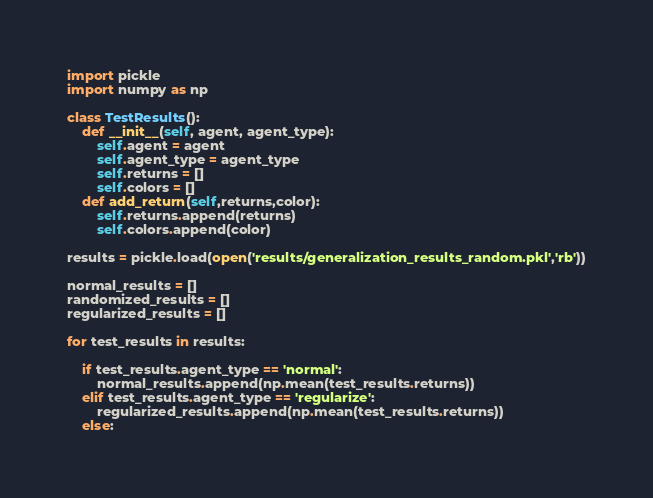Convert code to text. <code><loc_0><loc_0><loc_500><loc_500><_Python_>import pickle
import numpy as np

class TestResults():
    def __init__(self, agent, agent_type):
        self.agent = agent
        self.agent_type = agent_type
        self.returns = []
        self.colors = []
    def add_return(self,returns,color):
        self.returns.append(returns)
        self.colors.append(color)

results = pickle.load(open('results/generalization_results_random.pkl','rb'))

normal_results = []
randomized_results = []
regularized_results = []

for test_results in results:

    if test_results.agent_type == 'normal':
        normal_results.append(np.mean(test_results.returns))
    elif test_results.agent_type == 'regularize':
        regularized_results.append(np.mean(test_results.returns))
    else:</code> 